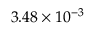<formula> <loc_0><loc_0><loc_500><loc_500>3 . 4 8 \times 1 0 ^ { - 3 }</formula> 